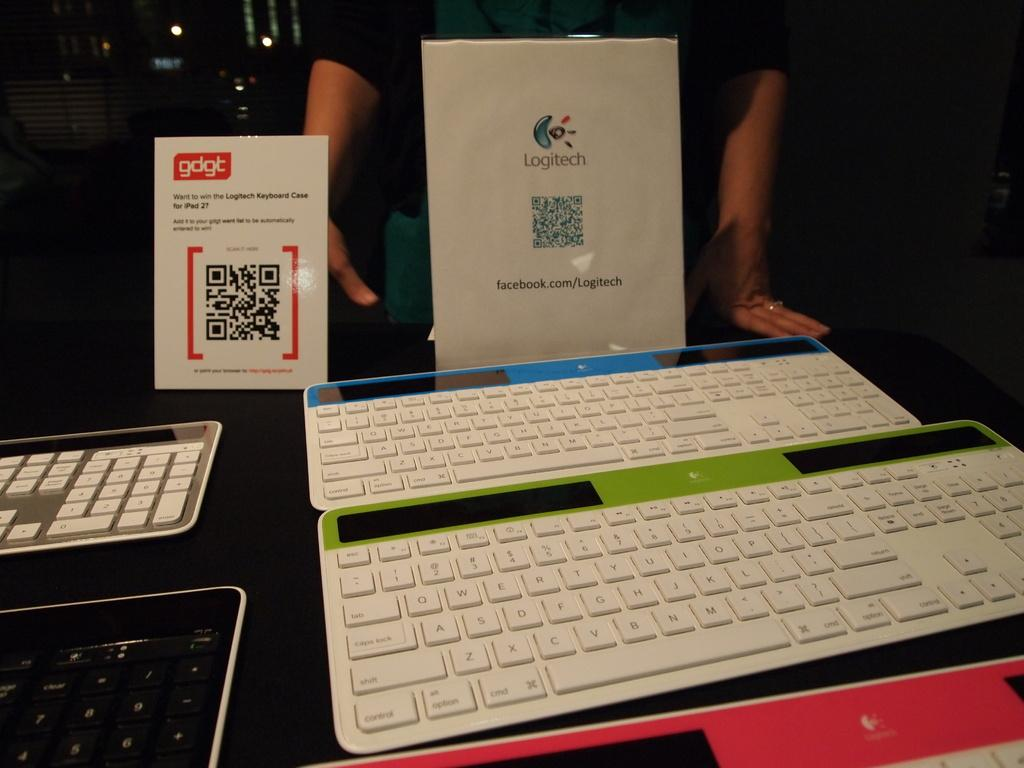<image>
Describe the image concisely. a keyboard in front of a paper that says 'logitech' on it 